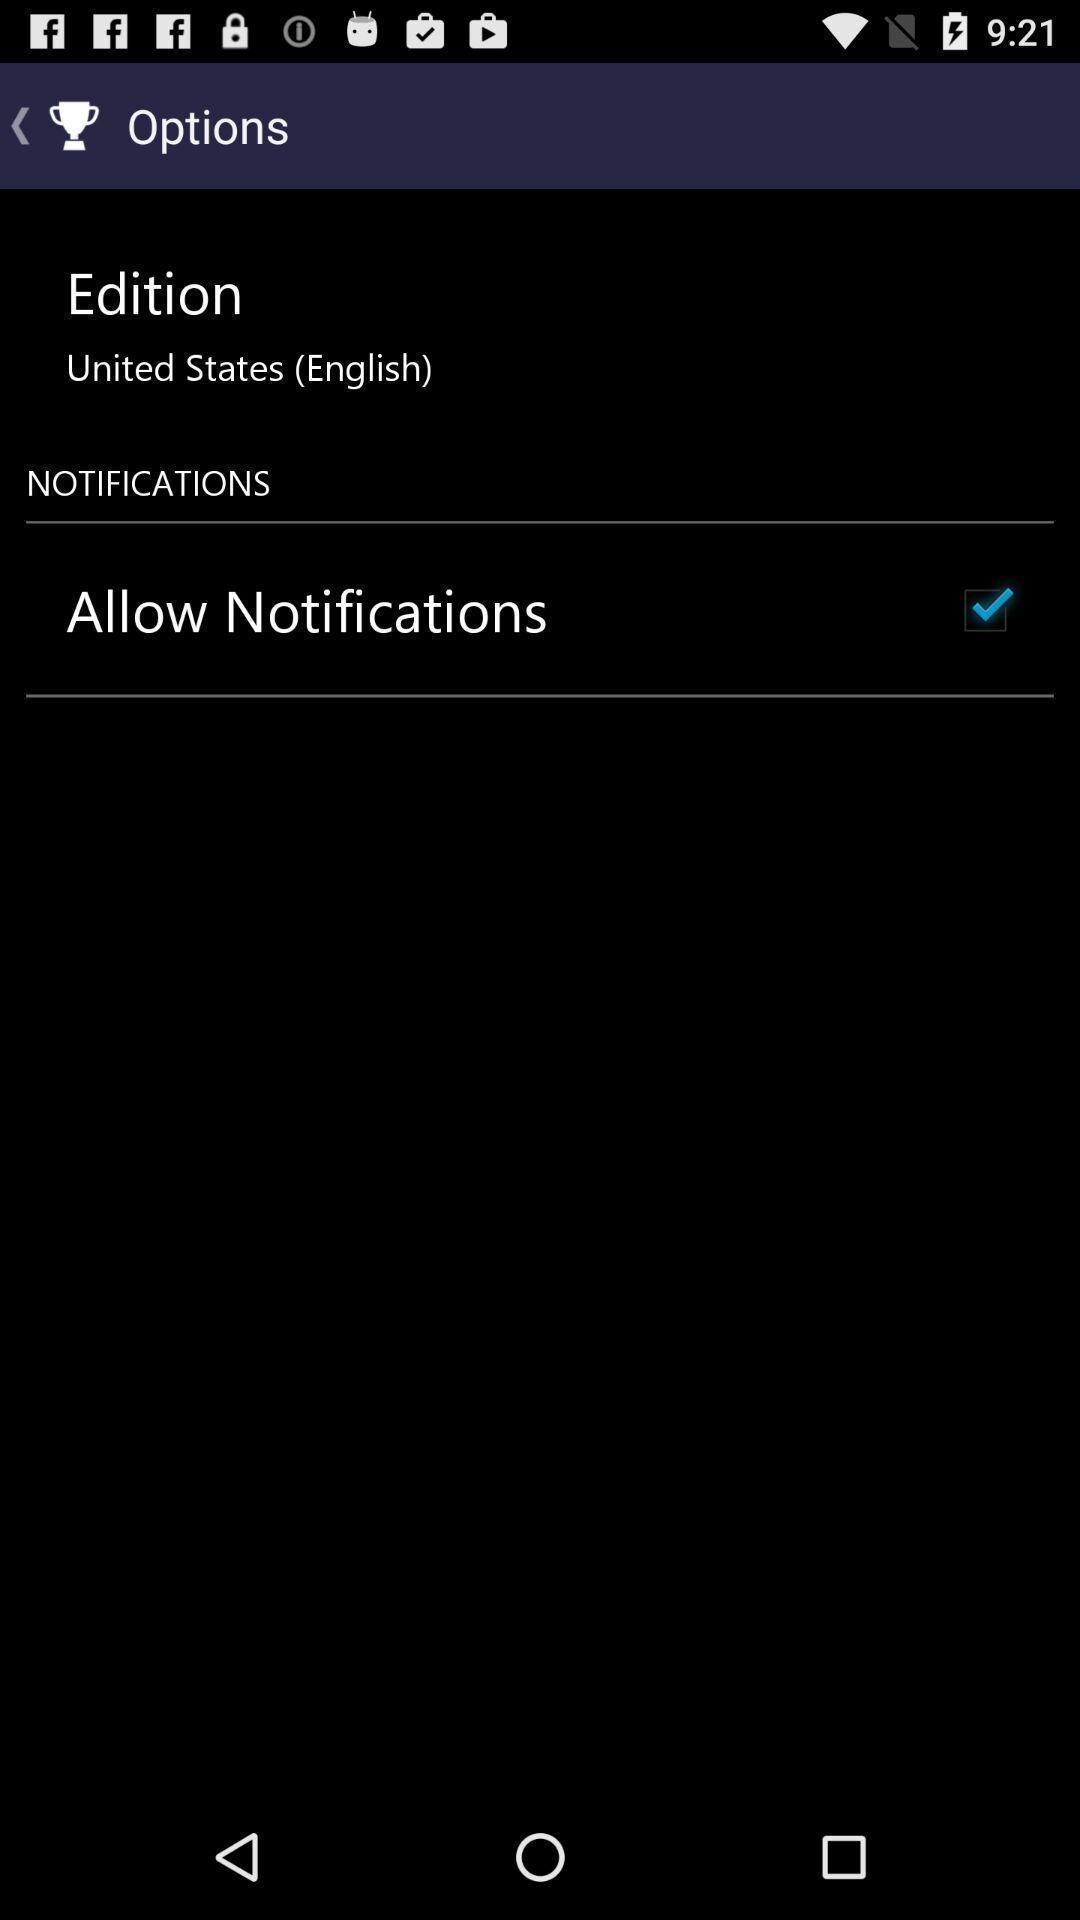Describe the content in this image. Page showing about different option available. 